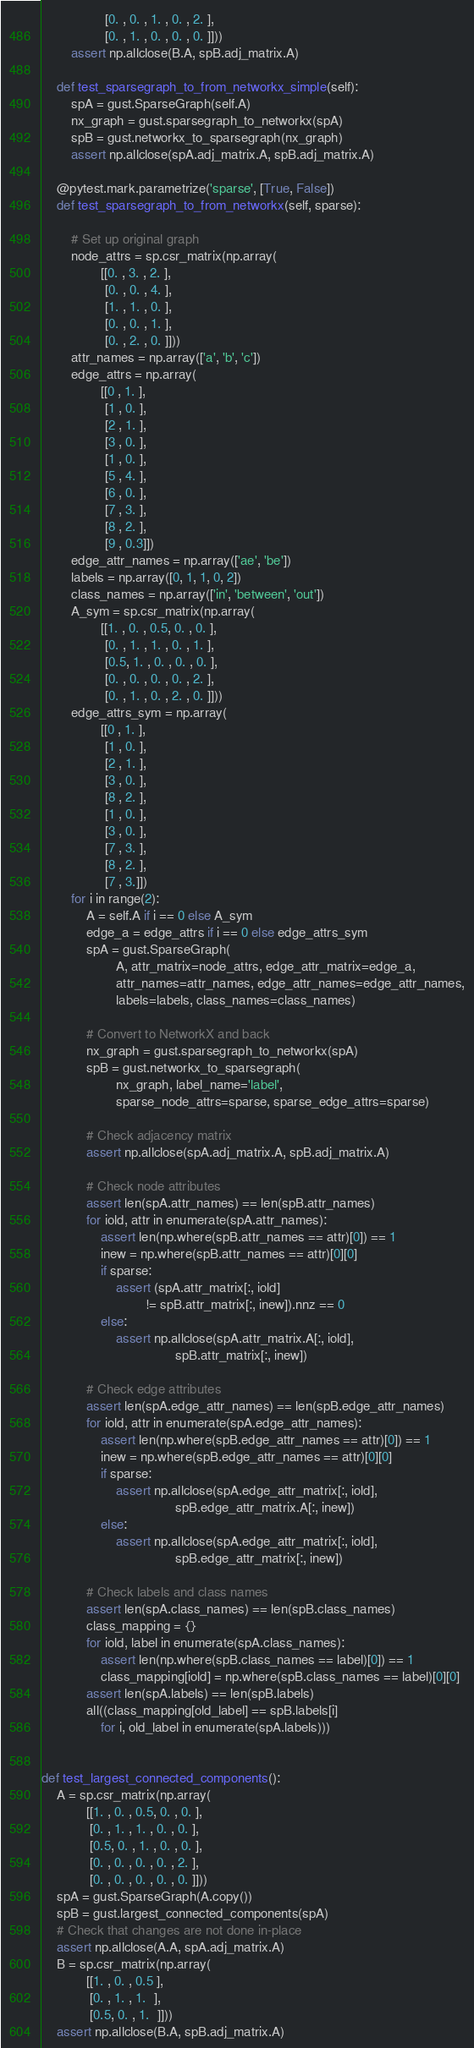<code> <loc_0><loc_0><loc_500><loc_500><_Python_>                 [0. , 0. , 1. , 0. , 2. ],
                 [0. , 1. , 0. , 0. , 0. ]]))
        assert np.allclose(B.A, spB.adj_matrix.A)

    def test_sparsegraph_to_from_networkx_simple(self):
        spA = gust.SparseGraph(self.A)
        nx_graph = gust.sparsegraph_to_networkx(spA)
        spB = gust.networkx_to_sparsegraph(nx_graph)
        assert np.allclose(spA.adj_matrix.A, spB.adj_matrix.A)

    @pytest.mark.parametrize('sparse', [True, False])
    def test_sparsegraph_to_from_networkx(self, sparse):

        # Set up original graph
        node_attrs = sp.csr_matrix(np.array(
                [[0. , 3. , 2. ],
                 [0. , 0. , 4. ],
                 [1. , 1. , 0. ],
                 [0. , 0. , 1. ],
                 [0. , 2. , 0. ]]))
        attr_names = np.array(['a', 'b', 'c'])
        edge_attrs = np.array(
                [[0 , 1. ],
                 [1 , 0. ],
                 [2 , 1. ],
                 [3 , 0. ],
                 [1 , 0. ],
                 [5 , 4. ],
                 [6 , 0. ],
                 [7 , 3. ],
                 [8 , 2. ],
                 [9 , 0.3]])
        edge_attr_names = np.array(['ae', 'be'])
        labels = np.array([0, 1, 1, 0, 2])
        class_names = np.array(['in', 'between', 'out'])
        A_sym = sp.csr_matrix(np.array(
                [[1. , 0. , 0.5, 0. , 0. ],
                 [0. , 1. , 1. , 0. , 1. ],
                 [0.5, 1. , 0. , 0. , 0. ],
                 [0. , 0. , 0. , 0. , 2. ],
                 [0. , 1. , 0. , 2. , 0. ]]))
        edge_attrs_sym = np.array(
                [[0 , 1. ],
                 [1 , 0. ],
                 [2 , 1. ],
                 [3 , 0. ],
                 [8 , 2. ],
                 [1 , 0. ],
                 [3 , 0. ],
                 [7 , 3. ],
                 [8 , 2. ],
                 [7 , 3.]])
        for i in range(2):
            A = self.A if i == 0 else A_sym
            edge_a = edge_attrs if i == 0 else edge_attrs_sym
            spA = gust.SparseGraph(
                    A, attr_matrix=node_attrs, edge_attr_matrix=edge_a,
                    attr_names=attr_names, edge_attr_names=edge_attr_names,
                    labels=labels, class_names=class_names)

            # Convert to NetworkX and back
            nx_graph = gust.sparsegraph_to_networkx(spA)
            spB = gust.networkx_to_sparsegraph(
                    nx_graph, label_name='label',
                    sparse_node_attrs=sparse, sparse_edge_attrs=sparse)

            # Check adjacency matrix
            assert np.allclose(spA.adj_matrix.A, spB.adj_matrix.A)

            # Check node attributes
            assert len(spA.attr_names) == len(spB.attr_names)
            for iold, attr in enumerate(spA.attr_names):
                assert len(np.where(spB.attr_names == attr)[0]) == 1
                inew = np.where(spB.attr_names == attr)[0][0]
                if sparse:
                    assert (spA.attr_matrix[:, iold]
                            != spB.attr_matrix[:, inew]).nnz == 0
                else:
                    assert np.allclose(spA.attr_matrix.A[:, iold],
                                    spB.attr_matrix[:, inew])

            # Check edge attributes
            assert len(spA.edge_attr_names) == len(spB.edge_attr_names)
            for iold, attr in enumerate(spA.edge_attr_names):
                assert len(np.where(spB.edge_attr_names == attr)[0]) == 1
                inew = np.where(spB.edge_attr_names == attr)[0][0]
                if sparse:
                    assert np.allclose(spA.edge_attr_matrix[:, iold],
                                    spB.edge_attr_matrix.A[:, inew])
                else:
                    assert np.allclose(spA.edge_attr_matrix[:, iold],
                                    spB.edge_attr_matrix[:, inew])

            # Check labels and class names
            assert len(spA.class_names) == len(spB.class_names)
            class_mapping = {}
            for iold, label in enumerate(spA.class_names):
                assert len(np.where(spB.class_names == label)[0]) == 1
                class_mapping[iold] = np.where(spB.class_names == label)[0][0]
            assert len(spA.labels) == len(spB.labels)
            all((class_mapping[old_label] == spB.labels[i]
                for i, old_label in enumerate(spA.labels)))


def test_largest_connected_components():
    A = sp.csr_matrix(np.array(
            [[1. , 0. , 0.5, 0. , 0. ],
             [0. , 1. , 1. , 0. , 0. ],
             [0.5, 0. , 1. , 0. , 0. ],
             [0. , 0. , 0. , 0. , 2. ],
             [0. , 0. , 0. , 0. , 0. ]]))
    spA = gust.SparseGraph(A.copy())
    spB = gust.largest_connected_components(spA)
    # Check that changes are not done in-place
    assert np.allclose(A.A, spA.adj_matrix.A)
    B = sp.csr_matrix(np.array(
            [[1. , 0. , 0.5 ],
             [0. , 1. , 1.  ],
             [0.5, 0. , 1.  ]]))
    assert np.allclose(B.A, spB.adj_matrix.A)

</code> 